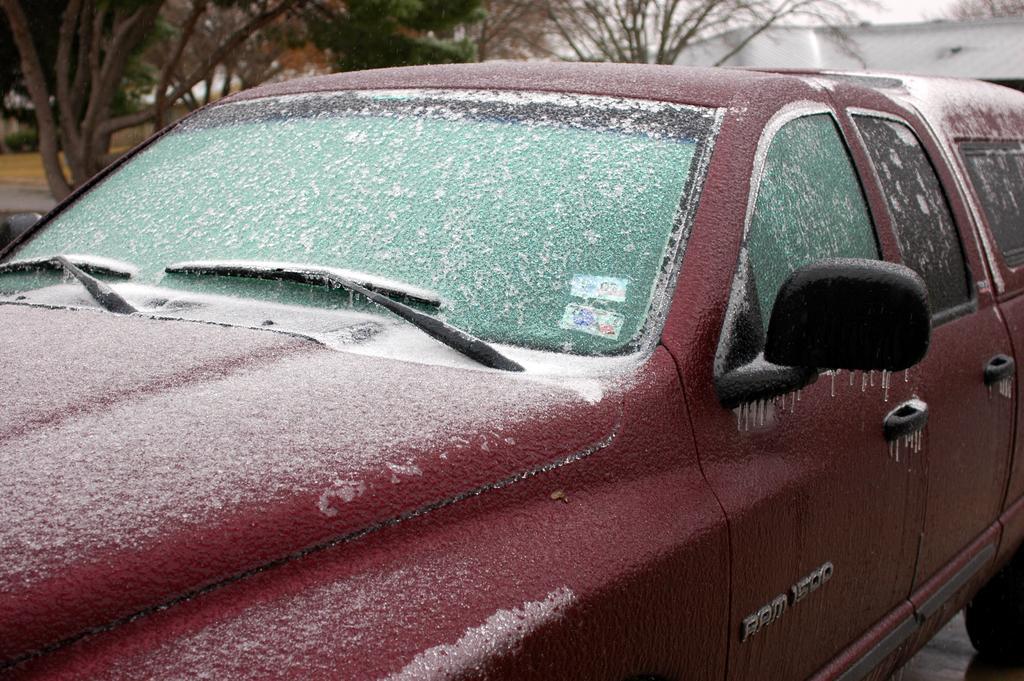In one or two sentences, can you explain what this image depicts? In the picture I can see a red color car which has the snow. In the background I can see trees and some other objects. 